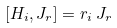Convert formula to latex. <formula><loc_0><loc_0><loc_500><loc_500>[ H _ { i } , J _ { r } ] = r _ { i } \, J _ { r }</formula> 